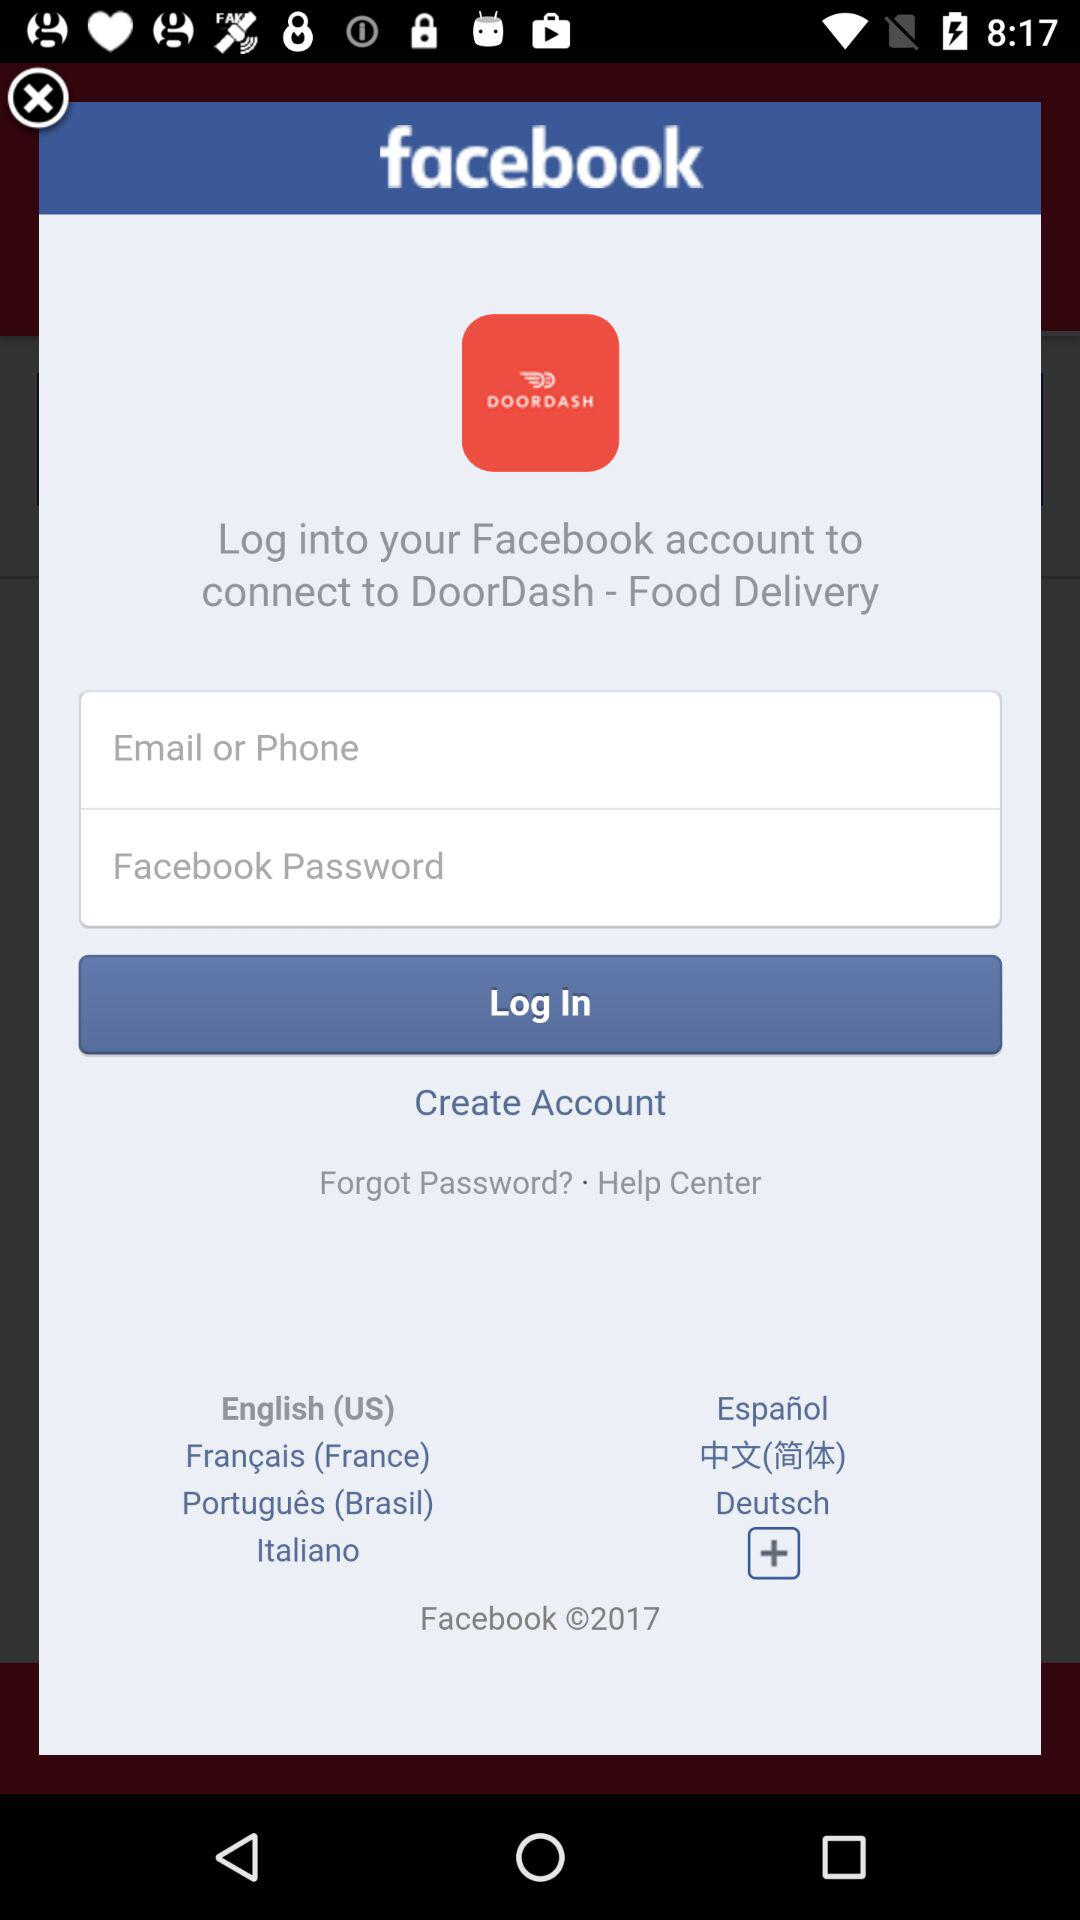Through which app can we log in to connect to "DoorDash"? You can log in through "Facebook". 